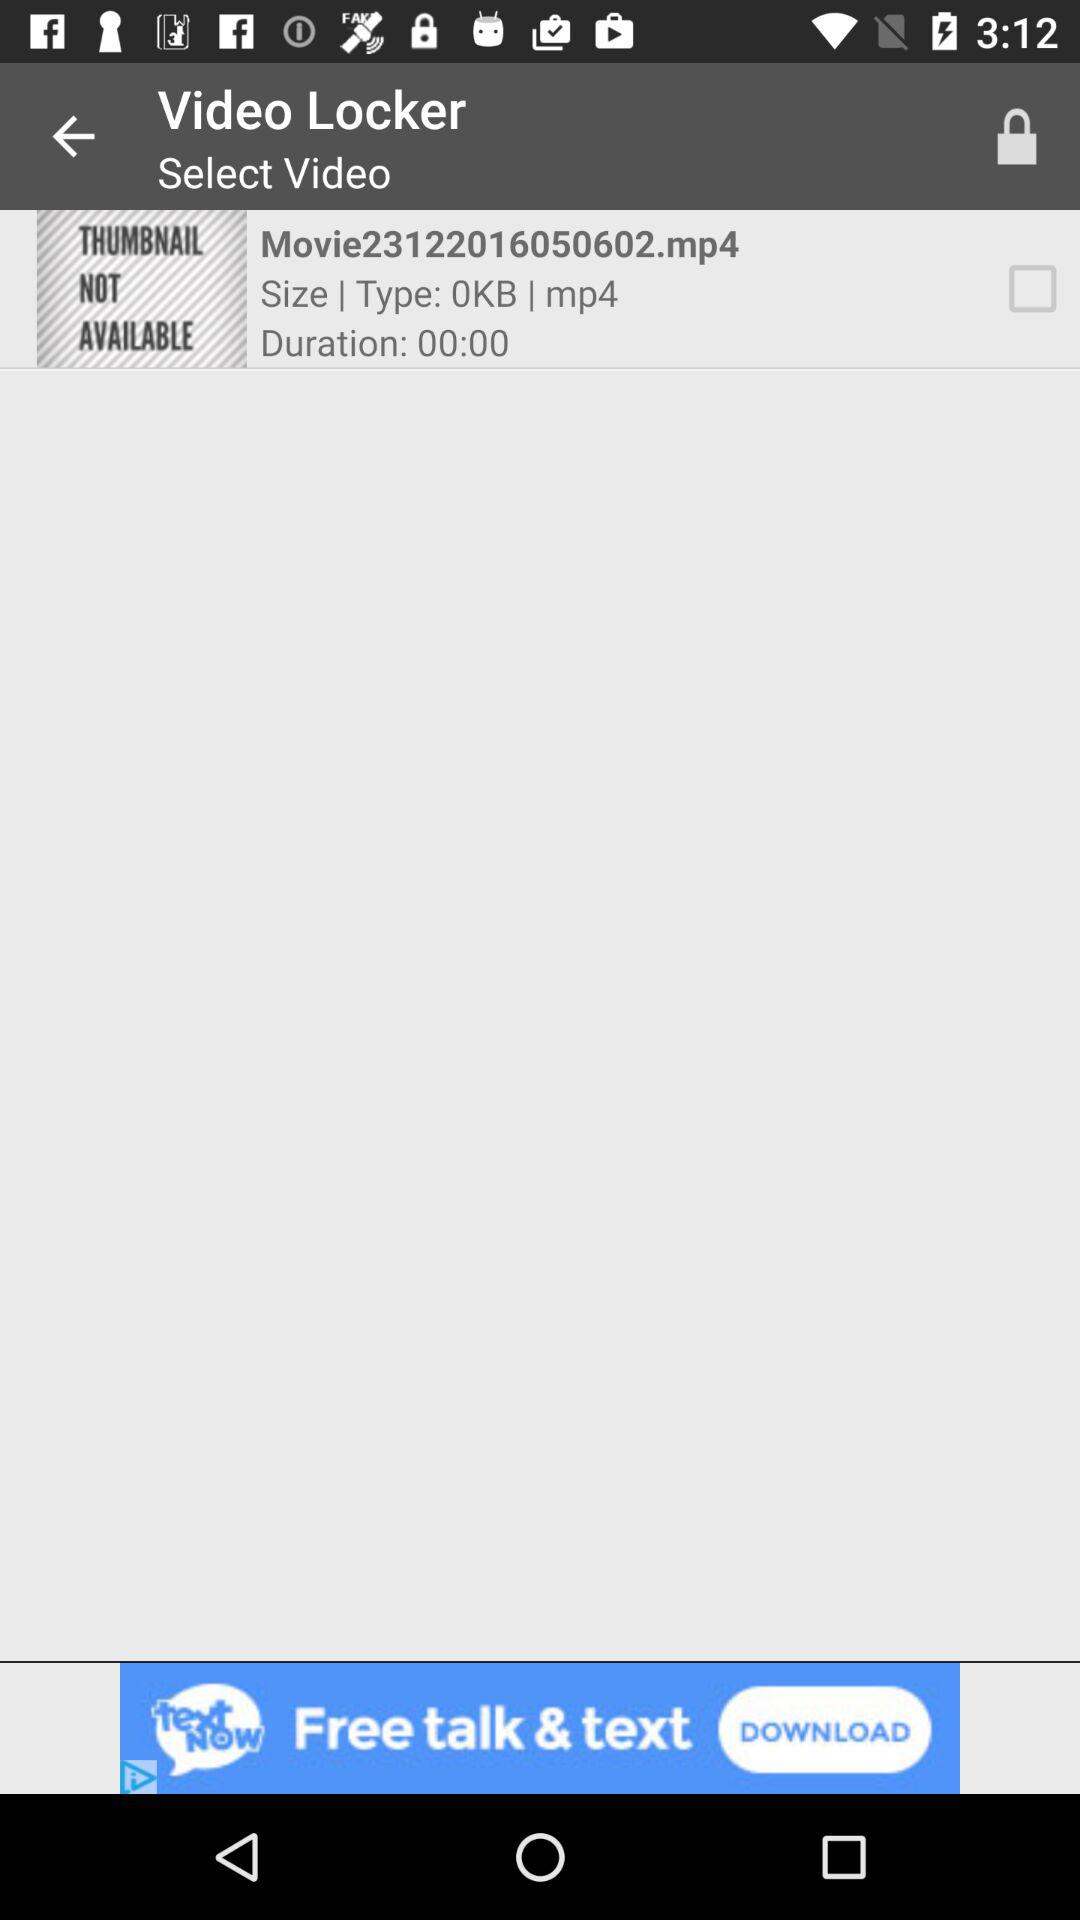What kind of file extension is used for the given video? The file extension is mp4. 